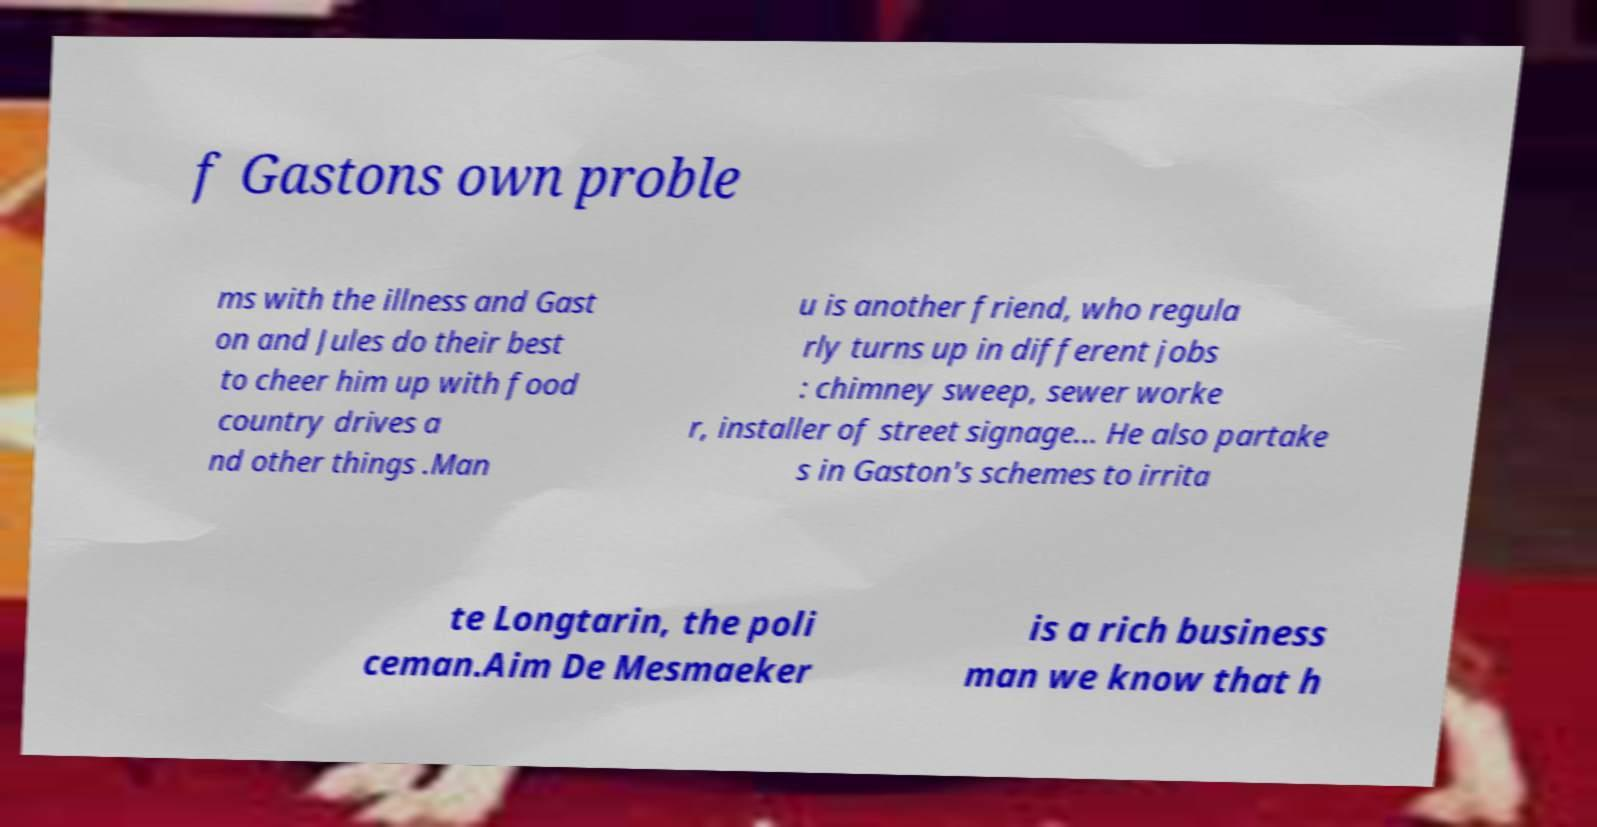Could you assist in decoding the text presented in this image and type it out clearly? f Gastons own proble ms with the illness and Gast on and Jules do their best to cheer him up with food country drives a nd other things .Man u is another friend, who regula rly turns up in different jobs : chimney sweep, sewer worke r, installer of street signage... He also partake s in Gaston's schemes to irrita te Longtarin, the poli ceman.Aim De Mesmaeker is a rich business man we know that h 